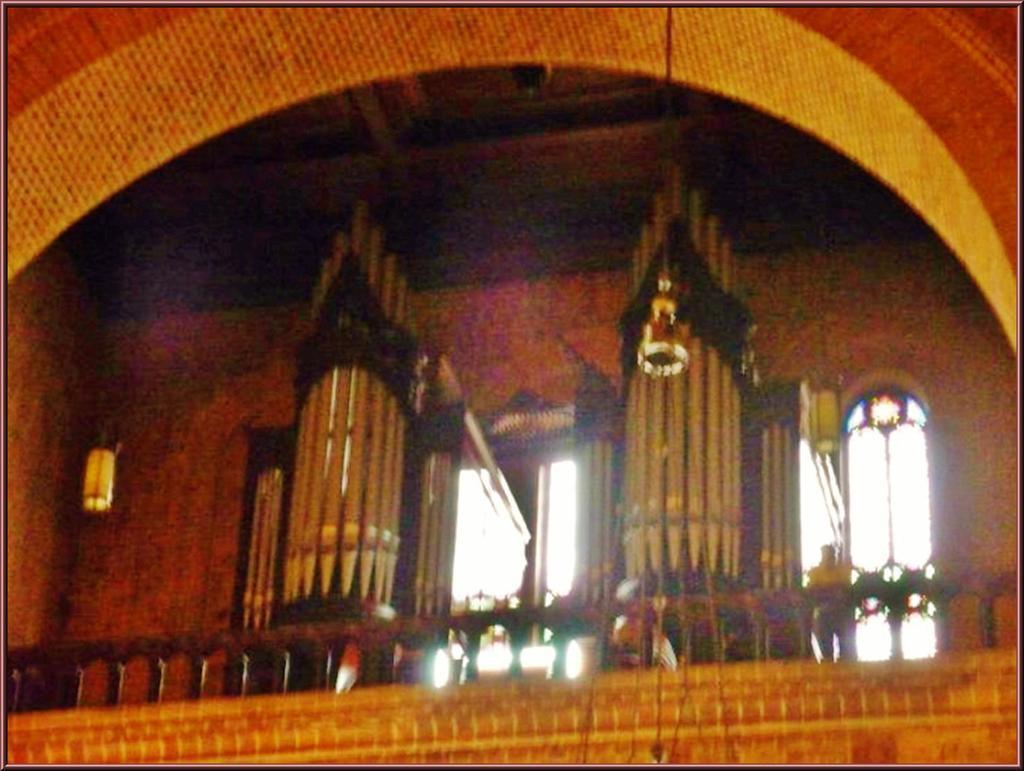How would you summarize this image in a sentence or two? In the picture we can see inside view of the building with some wall and railing to it and two doors with some decoration near it. 